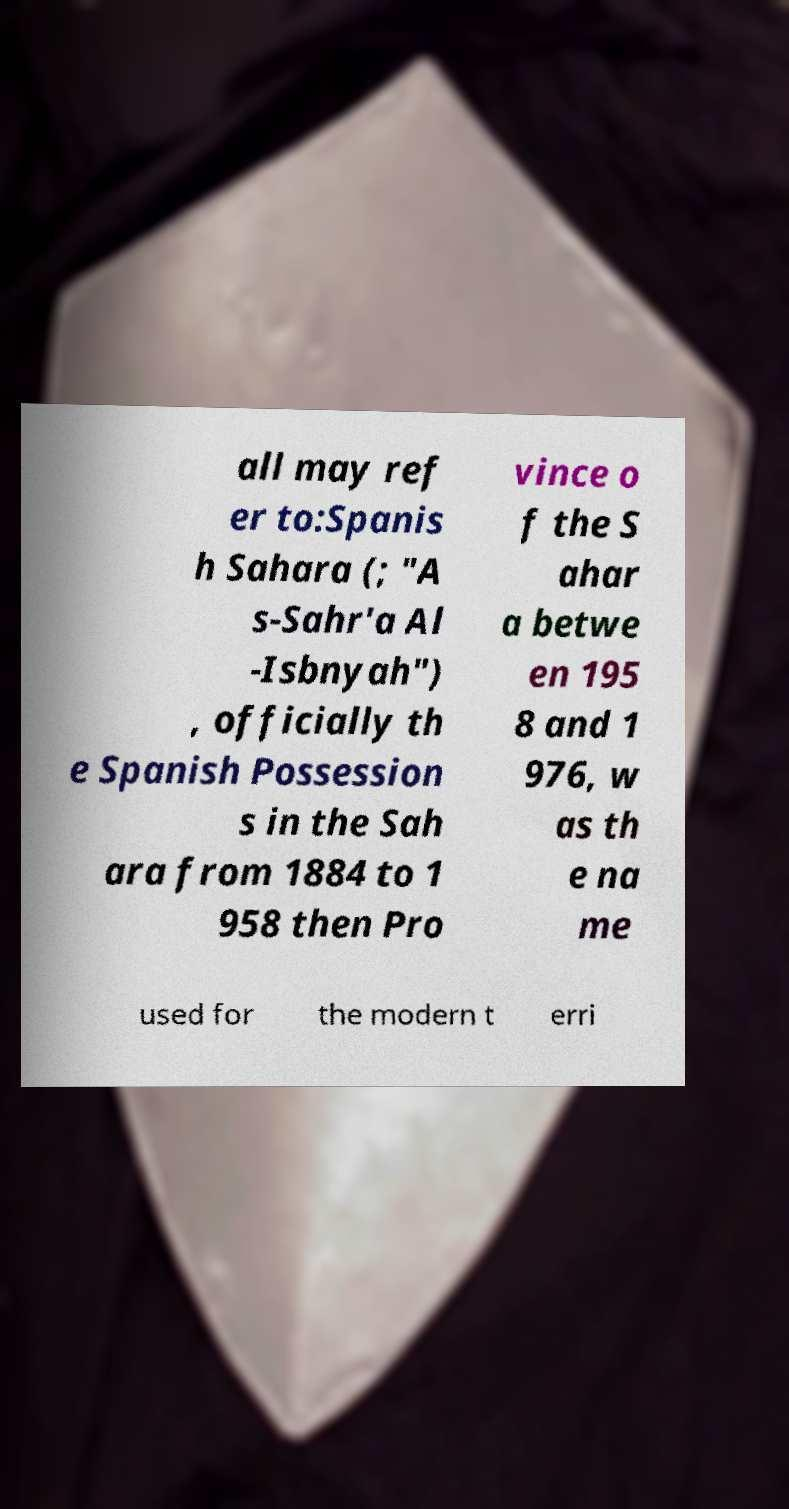Could you assist in decoding the text presented in this image and type it out clearly? all may ref er to:Spanis h Sahara (; "A s-Sahr'a Al -Isbnyah") , officially th e Spanish Possession s in the Sah ara from 1884 to 1 958 then Pro vince o f the S ahar a betwe en 195 8 and 1 976, w as th e na me used for the modern t erri 